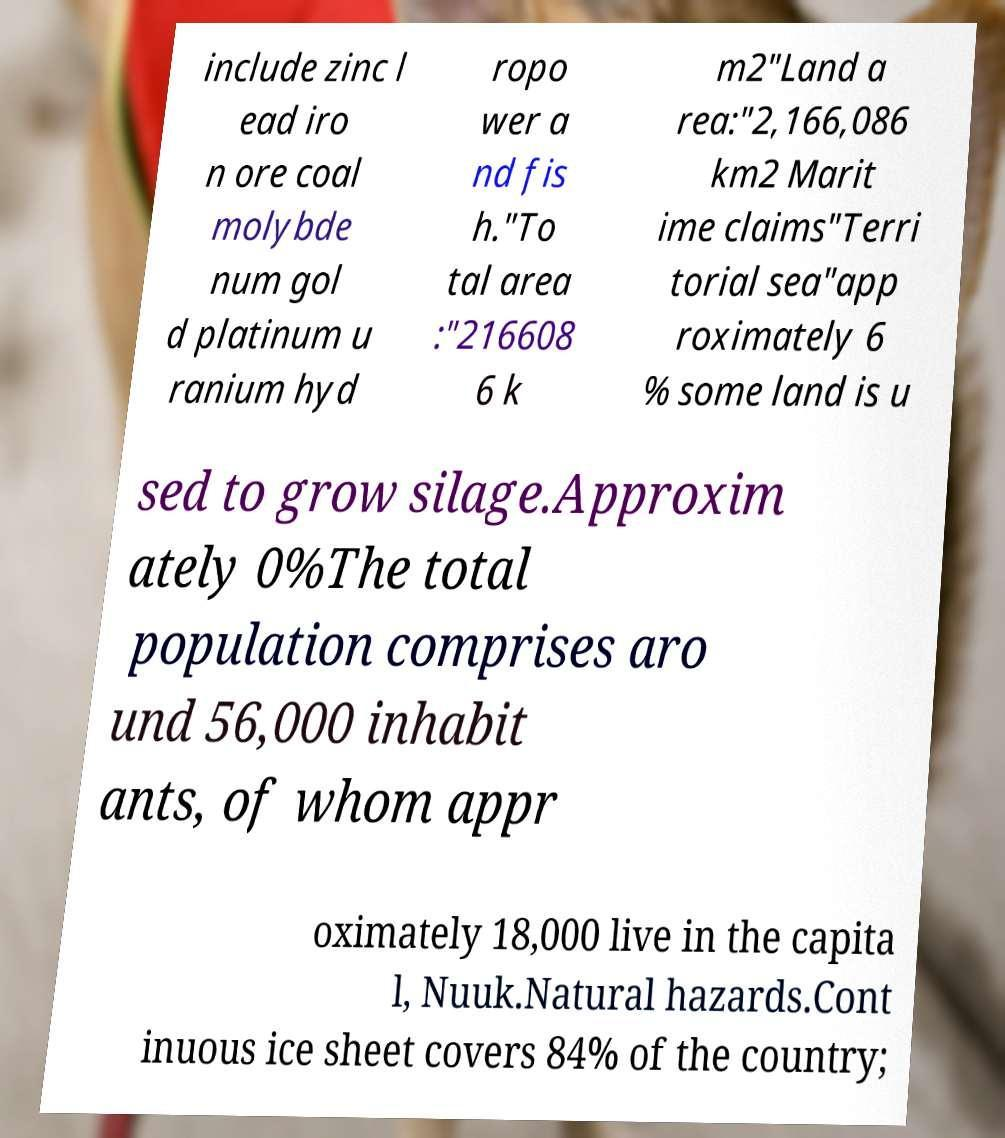For documentation purposes, I need the text within this image transcribed. Could you provide that? include zinc l ead iro n ore coal molybde num gol d platinum u ranium hyd ropo wer a nd fis h."To tal area :"216608 6 k m2"Land a rea:"2,166,086 km2 Marit ime claims"Terri torial sea"app roximately 6 % some land is u sed to grow silage.Approxim ately 0%The total population comprises aro und 56,000 inhabit ants, of whom appr oximately 18,000 live in the capita l, Nuuk.Natural hazards.Cont inuous ice sheet covers 84% of the country; 